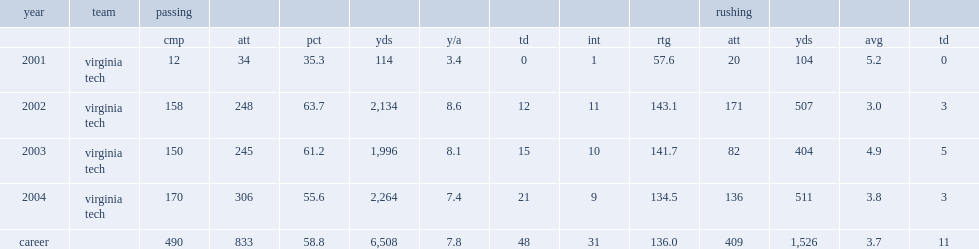In 2004, how many yards did randall have throwing for? 2264.0. In 2004, how many yards did randall have rushing for? 511.0. 